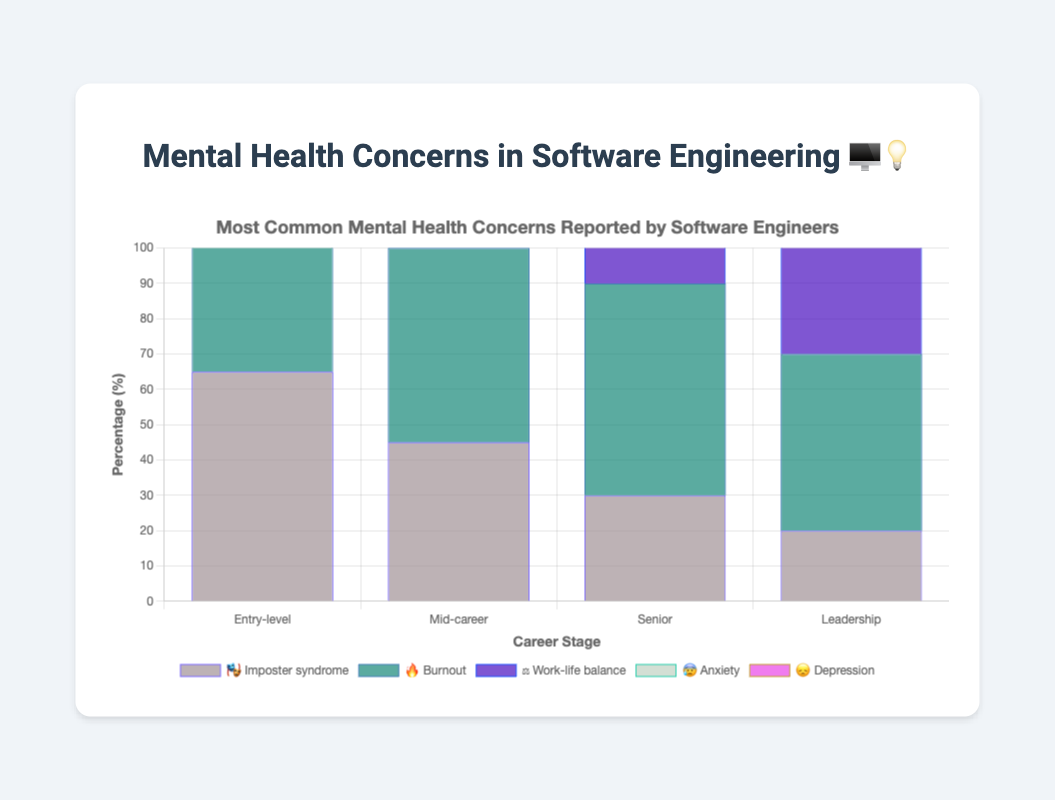What is the most common mental health concern for entry-level software engineers? By looking at the chart, locate the segment with the highest percentage for entry-level software engineers. The bar labeled "Imposter syndrome 🎭" has the highest value at 65%.
Answer: Imposter syndrome Which career stage reports the highest percentage of burnout? Identify the bar segment labeled "Burnout 🔥" and compare the percentages across all career stages. The highest percentage (60%) is reported by the Senior career stage.
Answer: Senior How does the percentage of anxiety change from entry-level to leadership positions? Find the "Anxiety 😰" percentages for both entry-level (50%) and leadership (35%) positions. Calculate the change: 50% - 35% = 15%.
Answer: Decreases by 15% What is the difference in the percentage of work-life balance concerns between entry-level and mid-career software engineers? Locate the "Work-life balance ⚖️" percentages for entry-level (30%) and mid-career (50%) engineers. Calculate the difference: 50% - 30% = 20%.
Answer: 20% Which mental health concern has the most consistent reporting across all career stages? Observe the variations in percentages for each concern across different stages. "Depression 😞" has the values (25%, 30%, 35%, 30%), showing the least variation.
Answer: Depression Compare the percentage of burnout concerns between entry-level and leadership stages. Find the "Burnout 🔥" percentages for entry-level (40%) and leadership (50%). Then, compare the two values.
Answer: Leadership is 10% higher Does the percentage of imposter syndrome concerns increase or decrease as career stages advance? Look at the "Imposter syndrome 🎭" percentages (65%, 45%, 30%, 20%) from entry-level to leadership. The percentages show a decreasing trend.
Answer: Decrease Calculate the average percentage of depression reported across all career stages. Sum the percentages for "Depression 😞" (25%, 30%, 35%, 30%) and divide by the number of stages (4). (25 + 30 + 35 + 30) / 4 = 30%.
Answer: 30% How does the percentage of work-life balance concerns compare between senior and leadership stages? Locate the "Work-life balance ⚖️" percentages for senior (65%) and leadership (70%). Compare the values.
Answer: Leadership is 5% higher 